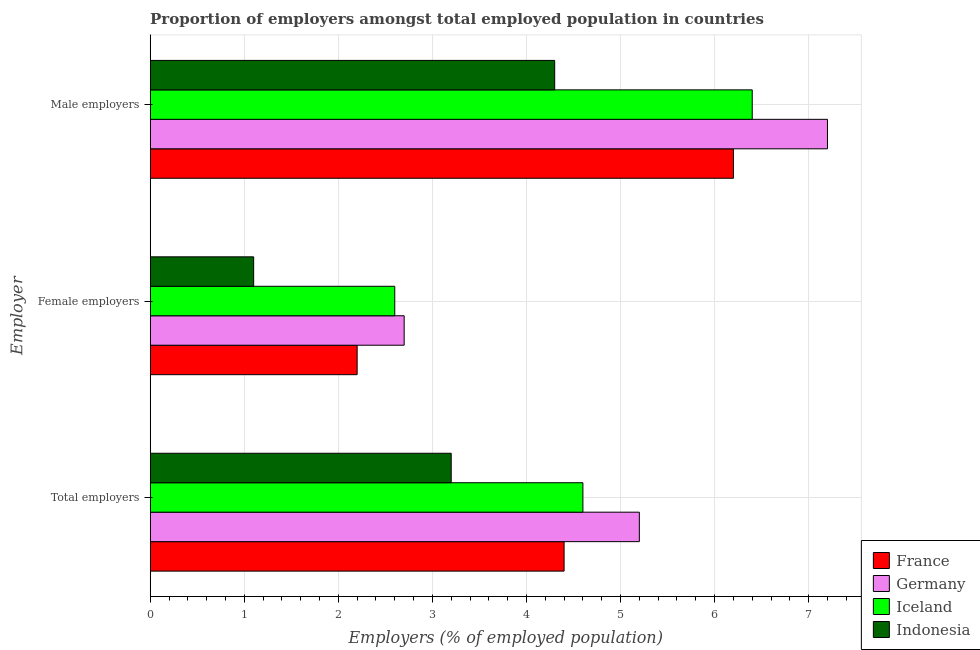How many different coloured bars are there?
Offer a very short reply. 4. How many bars are there on the 2nd tick from the bottom?
Keep it short and to the point. 4. What is the label of the 3rd group of bars from the top?
Your response must be concise. Total employers. What is the percentage of total employers in Indonesia?
Ensure brevity in your answer.  3.2. Across all countries, what is the maximum percentage of female employers?
Make the answer very short. 2.7. Across all countries, what is the minimum percentage of female employers?
Your response must be concise. 1.1. What is the total percentage of total employers in the graph?
Your answer should be very brief. 17.4. What is the difference between the percentage of male employers in Iceland and that in Germany?
Your answer should be compact. -0.8. What is the difference between the percentage of male employers in Iceland and the percentage of female employers in Indonesia?
Your answer should be compact. 5.3. What is the average percentage of male employers per country?
Your response must be concise. 6.02. What is the difference between the percentage of total employers and percentage of female employers in Indonesia?
Your response must be concise. 2.1. In how many countries, is the percentage of male employers greater than 3.2 %?
Make the answer very short. 4. What is the ratio of the percentage of total employers in Iceland to that in France?
Make the answer very short. 1.05. What is the difference between the highest and the second highest percentage of male employers?
Provide a succinct answer. 0.8. What is the difference between the highest and the lowest percentage of female employers?
Ensure brevity in your answer.  1.6. In how many countries, is the percentage of total employers greater than the average percentage of total employers taken over all countries?
Make the answer very short. 3. What does the 2nd bar from the top in Female employers represents?
Your answer should be compact. Iceland. What does the 4th bar from the bottom in Male employers represents?
Keep it short and to the point. Indonesia. Is it the case that in every country, the sum of the percentage of total employers and percentage of female employers is greater than the percentage of male employers?
Ensure brevity in your answer.  No. How many bars are there?
Keep it short and to the point. 12. Does the graph contain any zero values?
Your response must be concise. No. What is the title of the graph?
Give a very brief answer. Proportion of employers amongst total employed population in countries. Does "Kosovo" appear as one of the legend labels in the graph?
Your response must be concise. No. What is the label or title of the X-axis?
Offer a very short reply. Employers (% of employed population). What is the label or title of the Y-axis?
Your answer should be compact. Employer. What is the Employers (% of employed population) of France in Total employers?
Offer a very short reply. 4.4. What is the Employers (% of employed population) of Germany in Total employers?
Provide a short and direct response. 5.2. What is the Employers (% of employed population) of Iceland in Total employers?
Ensure brevity in your answer.  4.6. What is the Employers (% of employed population) of Indonesia in Total employers?
Your response must be concise. 3.2. What is the Employers (% of employed population) of France in Female employers?
Offer a very short reply. 2.2. What is the Employers (% of employed population) of Germany in Female employers?
Give a very brief answer. 2.7. What is the Employers (% of employed population) in Iceland in Female employers?
Offer a terse response. 2.6. What is the Employers (% of employed population) in Indonesia in Female employers?
Ensure brevity in your answer.  1.1. What is the Employers (% of employed population) in France in Male employers?
Keep it short and to the point. 6.2. What is the Employers (% of employed population) of Germany in Male employers?
Make the answer very short. 7.2. What is the Employers (% of employed population) in Iceland in Male employers?
Give a very brief answer. 6.4. What is the Employers (% of employed population) in Indonesia in Male employers?
Provide a short and direct response. 4.3. Across all Employer, what is the maximum Employers (% of employed population) in France?
Provide a succinct answer. 6.2. Across all Employer, what is the maximum Employers (% of employed population) of Germany?
Offer a terse response. 7.2. Across all Employer, what is the maximum Employers (% of employed population) in Iceland?
Keep it short and to the point. 6.4. Across all Employer, what is the maximum Employers (% of employed population) in Indonesia?
Give a very brief answer. 4.3. Across all Employer, what is the minimum Employers (% of employed population) of France?
Your answer should be compact. 2.2. Across all Employer, what is the minimum Employers (% of employed population) in Germany?
Your response must be concise. 2.7. Across all Employer, what is the minimum Employers (% of employed population) of Iceland?
Your answer should be compact. 2.6. Across all Employer, what is the minimum Employers (% of employed population) in Indonesia?
Offer a very short reply. 1.1. What is the total Employers (% of employed population) in France in the graph?
Offer a terse response. 12.8. What is the total Employers (% of employed population) in Iceland in the graph?
Provide a succinct answer. 13.6. What is the difference between the Employers (% of employed population) of Germany in Total employers and that in Female employers?
Keep it short and to the point. 2.5. What is the difference between the Employers (% of employed population) of Indonesia in Total employers and that in Female employers?
Give a very brief answer. 2.1. What is the difference between the Employers (% of employed population) of Germany in Total employers and that in Male employers?
Keep it short and to the point. -2. What is the difference between the Employers (% of employed population) in Indonesia in Total employers and that in Male employers?
Offer a terse response. -1.1. What is the difference between the Employers (% of employed population) of France in Female employers and that in Male employers?
Keep it short and to the point. -4. What is the difference between the Employers (% of employed population) of Iceland in Female employers and that in Male employers?
Make the answer very short. -3.8. What is the difference between the Employers (% of employed population) of Indonesia in Female employers and that in Male employers?
Your answer should be very brief. -3.2. What is the difference between the Employers (% of employed population) in France in Total employers and the Employers (% of employed population) in Germany in Female employers?
Provide a short and direct response. 1.7. What is the difference between the Employers (% of employed population) of France in Total employers and the Employers (% of employed population) of Iceland in Female employers?
Make the answer very short. 1.8. What is the difference between the Employers (% of employed population) in Germany in Total employers and the Employers (% of employed population) in Iceland in Female employers?
Your answer should be compact. 2.6. What is the difference between the Employers (% of employed population) of Germany in Total employers and the Employers (% of employed population) of Indonesia in Female employers?
Provide a succinct answer. 4.1. What is the difference between the Employers (% of employed population) in France in Total employers and the Employers (% of employed population) in Germany in Male employers?
Provide a short and direct response. -2.8. What is the difference between the Employers (% of employed population) of France in Total employers and the Employers (% of employed population) of Iceland in Male employers?
Make the answer very short. -2. What is the difference between the Employers (% of employed population) in Germany in Female employers and the Employers (% of employed population) in Iceland in Male employers?
Provide a short and direct response. -3.7. What is the difference between the Employers (% of employed population) in Germany in Female employers and the Employers (% of employed population) in Indonesia in Male employers?
Your answer should be compact. -1.6. What is the average Employers (% of employed population) in France per Employer?
Offer a very short reply. 4.27. What is the average Employers (% of employed population) of Germany per Employer?
Ensure brevity in your answer.  5.03. What is the average Employers (% of employed population) in Iceland per Employer?
Provide a short and direct response. 4.53. What is the average Employers (% of employed population) in Indonesia per Employer?
Give a very brief answer. 2.87. What is the difference between the Employers (% of employed population) in France and Employers (% of employed population) in Germany in Total employers?
Your answer should be compact. -0.8. What is the difference between the Employers (% of employed population) in Germany and Employers (% of employed population) in Indonesia in Total employers?
Your response must be concise. 2. What is the difference between the Employers (% of employed population) of Iceland and Employers (% of employed population) of Indonesia in Total employers?
Offer a very short reply. 1.4. What is the difference between the Employers (% of employed population) in France and Employers (% of employed population) in Germany in Female employers?
Provide a short and direct response. -0.5. What is the difference between the Employers (% of employed population) in France and Employers (% of employed population) in Indonesia in Female employers?
Your response must be concise. 1.1. What is the difference between the Employers (% of employed population) in Germany and Employers (% of employed population) in Iceland in Female employers?
Your answer should be very brief. 0.1. What is the difference between the Employers (% of employed population) in France and Employers (% of employed population) in Indonesia in Male employers?
Give a very brief answer. 1.9. What is the difference between the Employers (% of employed population) in Germany and Employers (% of employed population) in Iceland in Male employers?
Ensure brevity in your answer.  0.8. What is the difference between the Employers (% of employed population) in Germany and Employers (% of employed population) in Indonesia in Male employers?
Ensure brevity in your answer.  2.9. What is the difference between the Employers (% of employed population) in Iceland and Employers (% of employed population) in Indonesia in Male employers?
Your answer should be very brief. 2.1. What is the ratio of the Employers (% of employed population) of Germany in Total employers to that in Female employers?
Provide a succinct answer. 1.93. What is the ratio of the Employers (% of employed population) in Iceland in Total employers to that in Female employers?
Give a very brief answer. 1.77. What is the ratio of the Employers (% of employed population) of Indonesia in Total employers to that in Female employers?
Provide a short and direct response. 2.91. What is the ratio of the Employers (% of employed population) of France in Total employers to that in Male employers?
Your answer should be compact. 0.71. What is the ratio of the Employers (% of employed population) in Germany in Total employers to that in Male employers?
Make the answer very short. 0.72. What is the ratio of the Employers (% of employed population) in Iceland in Total employers to that in Male employers?
Give a very brief answer. 0.72. What is the ratio of the Employers (% of employed population) in Indonesia in Total employers to that in Male employers?
Your answer should be very brief. 0.74. What is the ratio of the Employers (% of employed population) in France in Female employers to that in Male employers?
Your response must be concise. 0.35. What is the ratio of the Employers (% of employed population) in Iceland in Female employers to that in Male employers?
Keep it short and to the point. 0.41. What is the ratio of the Employers (% of employed population) in Indonesia in Female employers to that in Male employers?
Provide a succinct answer. 0.26. What is the difference between the highest and the second highest Employers (% of employed population) in France?
Offer a terse response. 1.8. What is the difference between the highest and the second highest Employers (% of employed population) of Germany?
Keep it short and to the point. 2. What is the difference between the highest and the second highest Employers (% of employed population) in Indonesia?
Your response must be concise. 1.1. What is the difference between the highest and the lowest Employers (% of employed population) of France?
Offer a terse response. 4. 